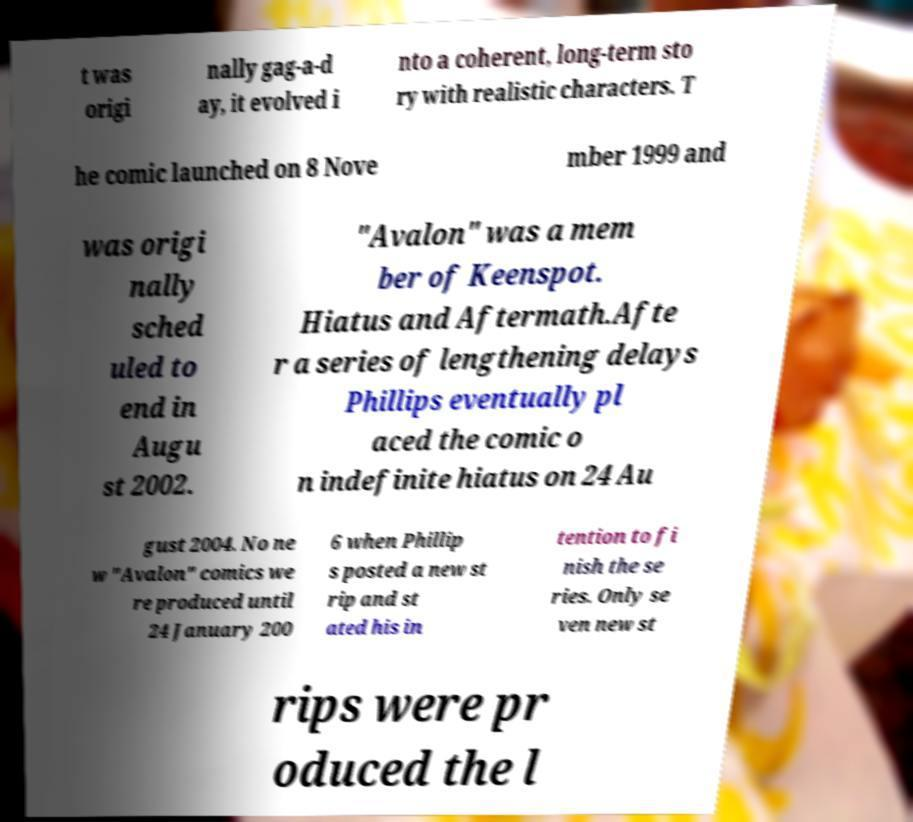Can you accurately transcribe the text from the provided image for me? t was origi nally gag-a-d ay, it evolved i nto a coherent, long-term sto ry with realistic characters. T he comic launched on 8 Nove mber 1999 and was origi nally sched uled to end in Augu st 2002. "Avalon" was a mem ber of Keenspot. Hiatus and Aftermath.Afte r a series of lengthening delays Phillips eventually pl aced the comic o n indefinite hiatus on 24 Au gust 2004. No ne w "Avalon" comics we re produced until 24 January 200 6 when Phillip s posted a new st rip and st ated his in tention to fi nish the se ries. Only se ven new st rips were pr oduced the l 